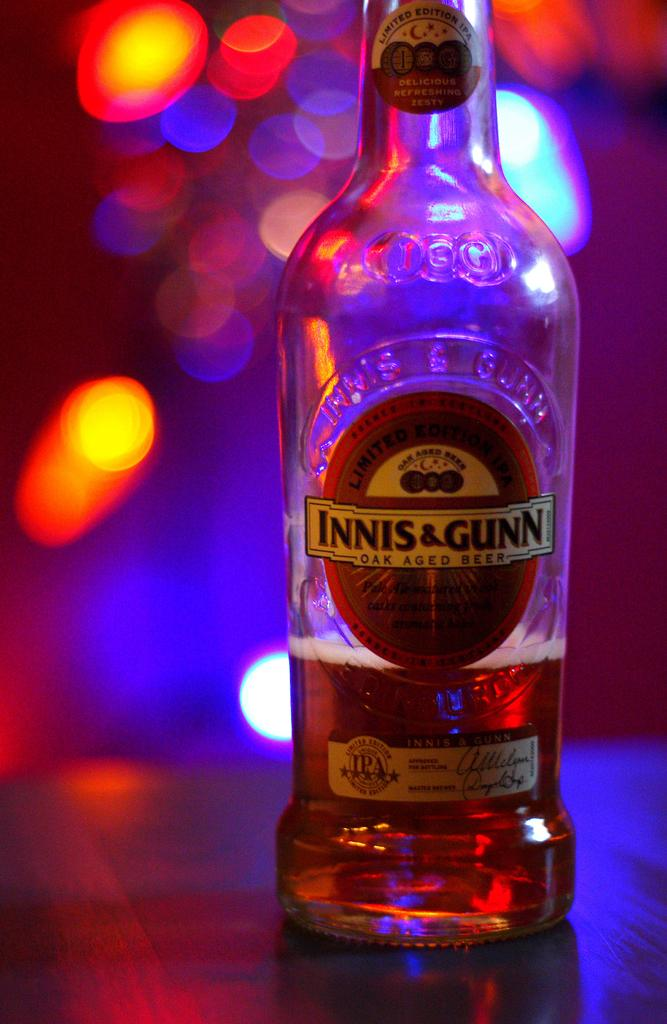<image>
Present a compact description of the photo's key features. A bottle of beer has an INNIS & GUNN label on it. 